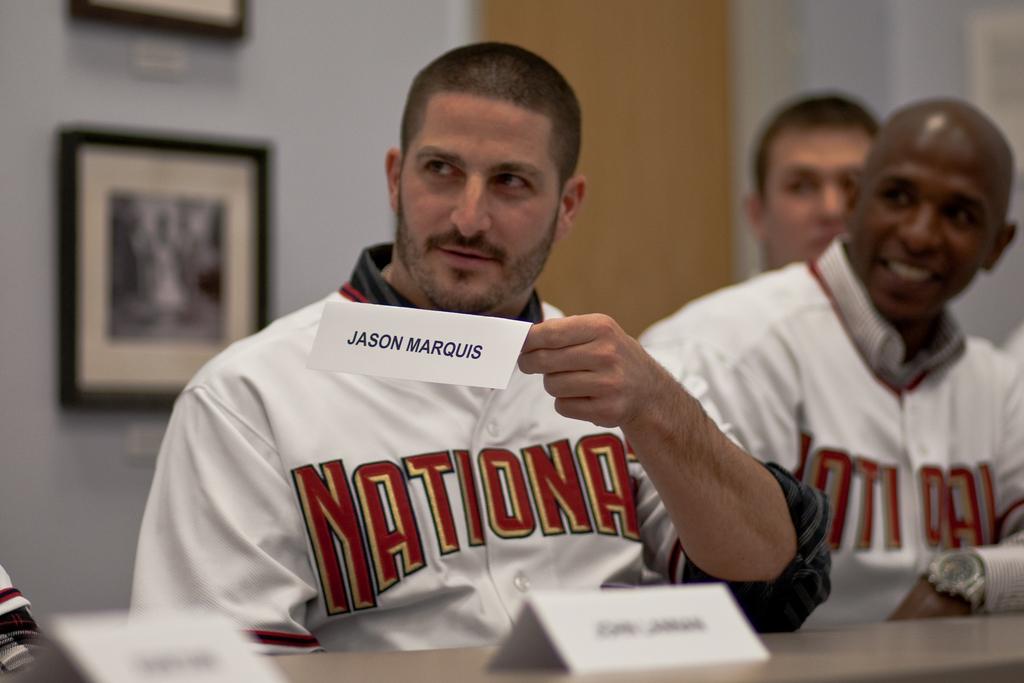What is this mans name?
Make the answer very short. Jason marquis. 